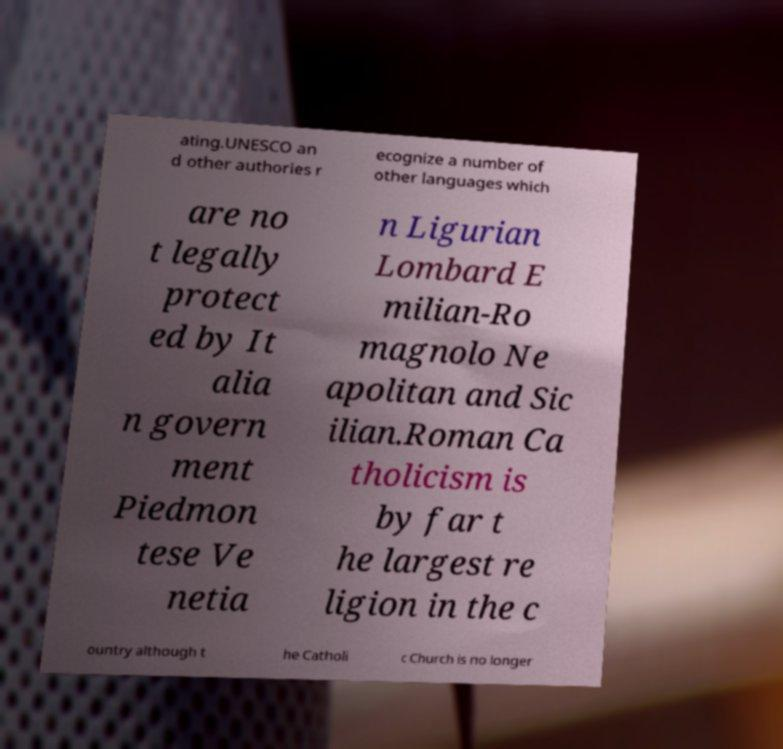Can you accurately transcribe the text from the provided image for me? ating.UNESCO an d other authories r ecognize a number of other languages which are no t legally protect ed by It alia n govern ment Piedmon tese Ve netia n Ligurian Lombard E milian-Ro magnolo Ne apolitan and Sic ilian.Roman Ca tholicism is by far t he largest re ligion in the c ountry although t he Catholi c Church is no longer 